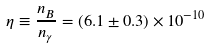Convert formula to latex. <formula><loc_0><loc_0><loc_500><loc_500>\eta \equiv \frac { n _ { B } } { n _ { \gamma } } = ( 6 . 1 \pm 0 . 3 ) \times 1 0 ^ { - 1 0 }</formula> 